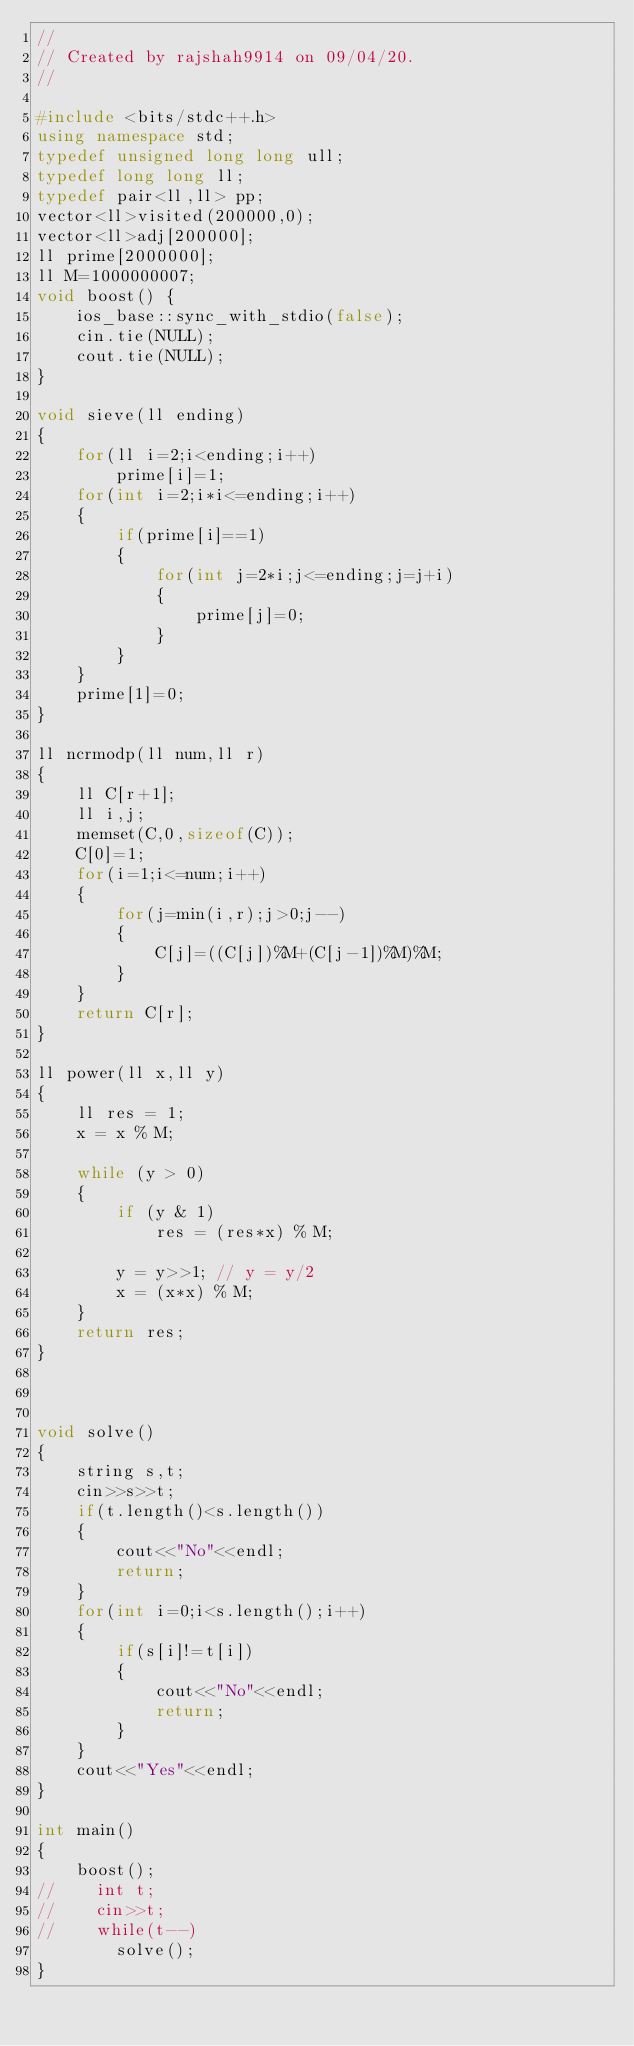Convert code to text. <code><loc_0><loc_0><loc_500><loc_500><_C++_>//
// Created by rajshah9914 on 09/04/20.
//

#include <bits/stdc++.h>
using namespace std;
typedef unsigned long long ull;
typedef long long ll;
typedef pair<ll,ll> pp;
vector<ll>visited(200000,0);
vector<ll>adj[200000];
ll prime[2000000];
ll M=1000000007;
void boost() {
    ios_base::sync_with_stdio(false);
    cin.tie(NULL);
    cout.tie(NULL);
}

void sieve(ll ending)
{
    for(ll i=2;i<ending;i++)
        prime[i]=1;
    for(int i=2;i*i<=ending;i++)
    {
        if(prime[i]==1)
        {
            for(int j=2*i;j<=ending;j=j+i)
            {
                prime[j]=0;
            }
        }
    }
    prime[1]=0;
}

ll ncrmodp(ll num,ll r)
{
    ll C[r+1];
    ll i,j;
    memset(C,0,sizeof(C));
    C[0]=1;
    for(i=1;i<=num;i++)
    {
        for(j=min(i,r);j>0;j--)
        {
            C[j]=((C[j])%M+(C[j-1])%M)%M;
        }
    }
    return C[r];
}

ll power(ll x,ll y)
{
    ll res = 1;
    x = x % M;

    while (y > 0)
    {
        if (y & 1)
            res = (res*x) % M;

        y = y>>1; // y = y/2
        x = (x*x) % M;
    }
    return res;
}



void solve()
{
    string s,t;
    cin>>s>>t;
    if(t.length()<s.length())
    {
        cout<<"No"<<endl;
        return;
    }
    for(int i=0;i<s.length();i++)
    {
        if(s[i]!=t[i])
        {
            cout<<"No"<<endl;
            return;
        }
    }
    cout<<"Yes"<<endl;
}

int main()
{
    boost();
//    int t;
//    cin>>t;
//    while(t--)
        solve();
}</code> 